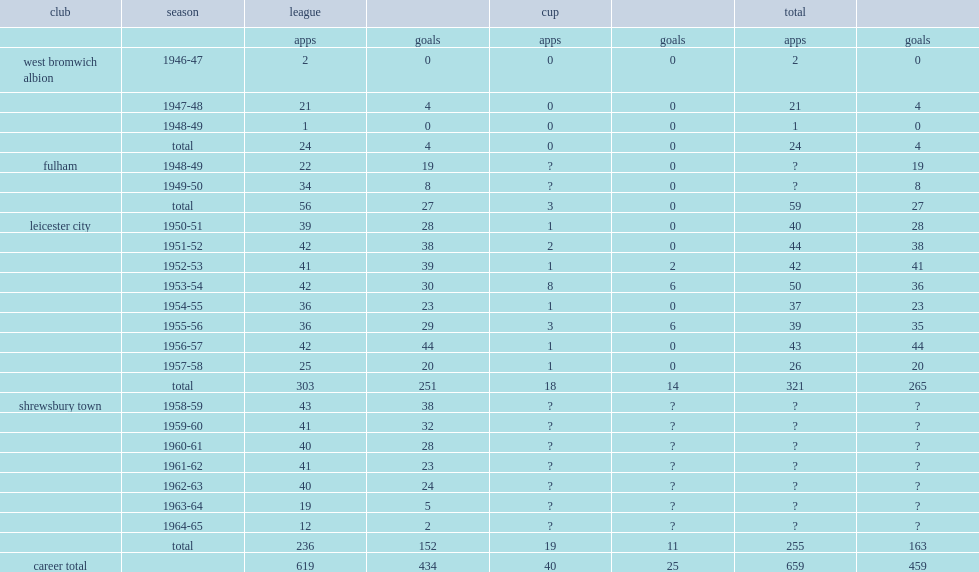With shrewsbury, how many league goals did arthur rowley score? 152.0. 